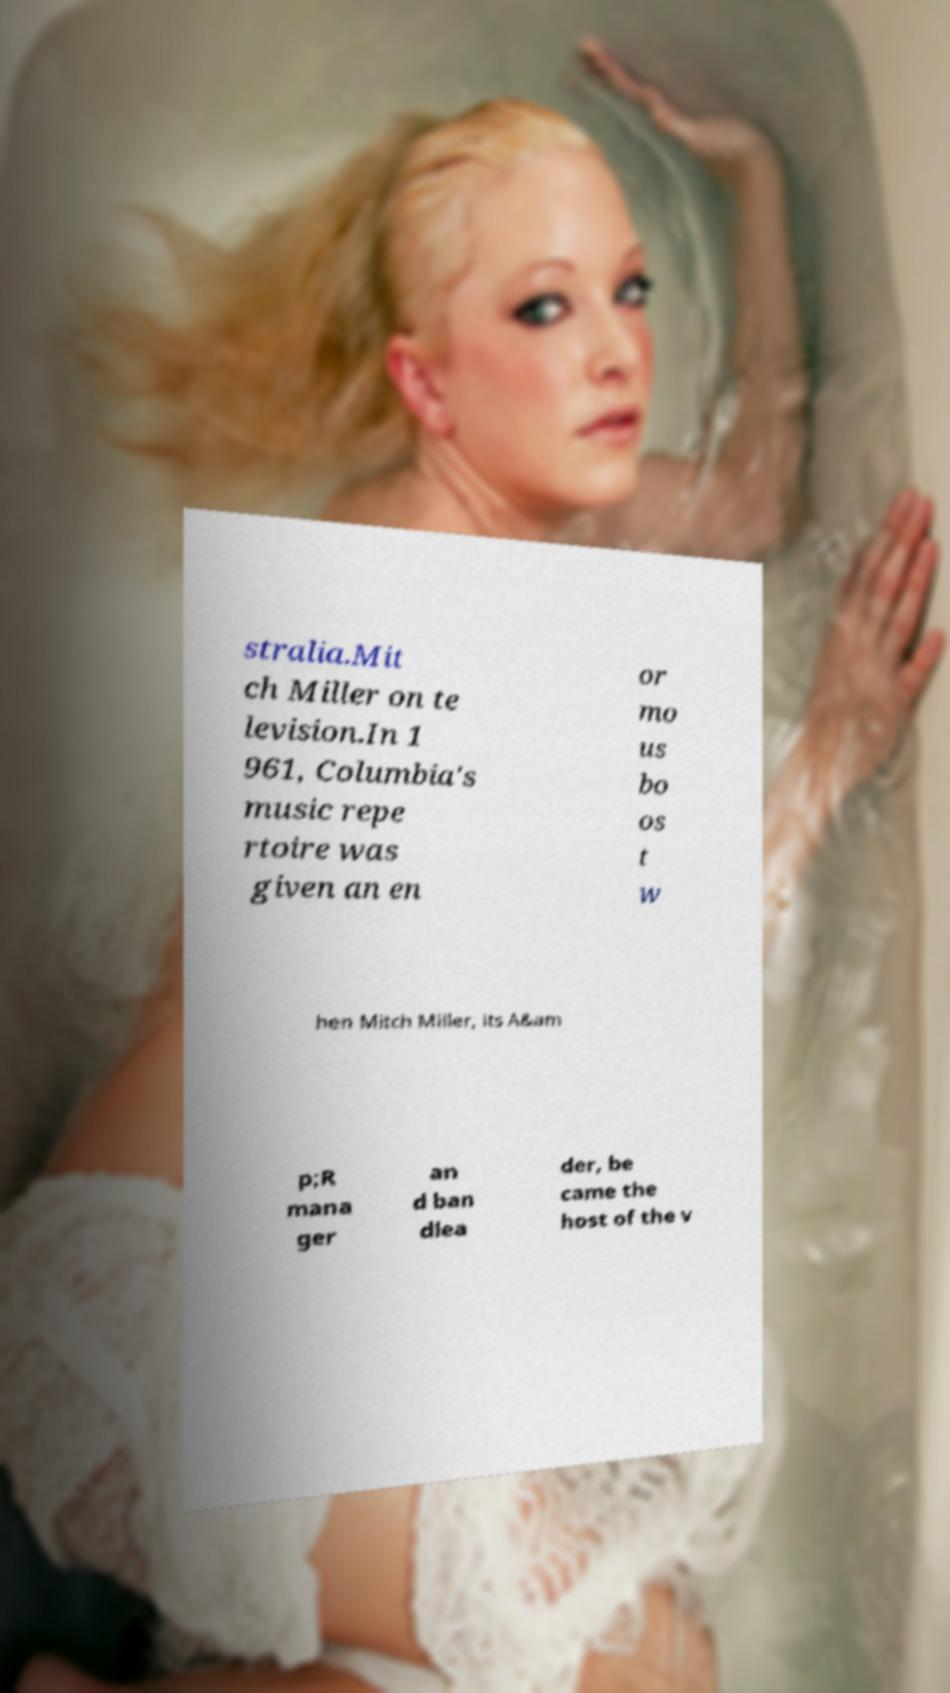Could you extract and type out the text from this image? stralia.Mit ch Miller on te levision.In 1 961, Columbia's music repe rtoire was given an en or mo us bo os t w hen Mitch Miller, its A&am p;R mana ger an d ban dlea der, be came the host of the v 